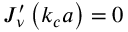<formula> <loc_0><loc_0><loc_500><loc_500>\begin{array} { r } { J _ { \nu } ^ { \prime } \left ( k _ { c } a \right ) = 0 } \end{array}</formula> 